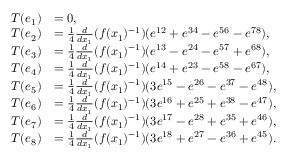<formula> <loc_0><loc_0><loc_500><loc_500>\begin{array} { r l } { T ( e _ { 1 } ) } & { = 0 , } \\ { T ( e _ { 2 } ) } & { = \frac { 1 } { 4 } \frac { d } { d x _ { 1 } } ( f ( x _ { 1 } ) ^ { - 1 } ) ( e ^ { 1 2 } + e ^ { 3 4 } - e ^ { 5 6 } - e ^ { 7 8 } ) , } \\ { T ( e _ { 3 } ) } & { = \frac { 1 } { 4 } \frac { d } { d x _ { 1 } } ( f ( x _ { 1 } ) ^ { - 1 } ) ( e ^ { 1 3 } - e ^ { 2 4 } - e ^ { 5 7 } + e ^ { 6 8 } ) , } \\ { T ( e _ { 4 } ) } & { = \frac { 1 } { 4 } \frac { d } { d x _ { 1 } } ( f ( x _ { 1 } ) ^ { - 1 } ) ( e ^ { 1 4 } + e ^ { 2 3 } - e ^ { 5 8 } - e ^ { 6 7 } ) , } \\ { T ( e _ { 5 } ) } & { = \frac { 1 } { 4 } \frac { d } { d x _ { 1 } } ( f ( x _ { 1 } ) ^ { - 1 } ) ( 3 e ^ { 1 5 } - e ^ { 2 6 } - e ^ { 3 7 } - e ^ { 4 8 } ) , } \\ { T ( e _ { 6 } ) } & { = \frac { 1 } { 4 } \frac { d } { d x _ { 1 } } ( f ( x _ { 1 } ) ^ { - 1 } ) ( 3 e ^ { 1 6 } + e ^ { 2 5 } + e ^ { 3 8 } - e ^ { 4 7 } ) , } \\ { T ( e _ { 7 } ) } & { = \frac { 1 } { 4 } \frac { d } { d x _ { 1 } } ( f ( x _ { 1 } ) ^ { - 1 } ) ( 3 e ^ { 1 7 } - e ^ { 2 8 } + e ^ { 3 5 } + e ^ { 4 6 } ) , } \\ { T ( e _ { 8 } ) } & { = \frac { 1 } { 4 } \frac { d } { d x _ { 1 } } ( f ( x _ { 1 } ) ^ { - 1 } ) ( 3 e ^ { 1 8 } + e ^ { 2 7 } - e ^ { 3 6 } + e ^ { 4 5 } ) . } \end{array}</formula> 